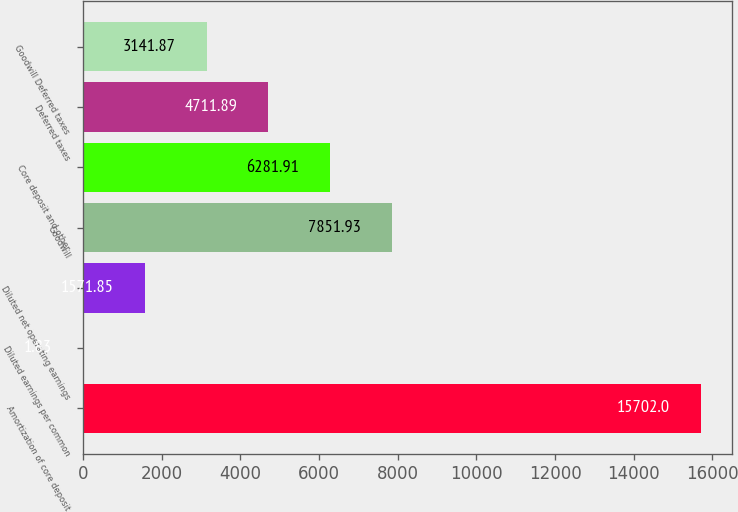Convert chart to OTSL. <chart><loc_0><loc_0><loc_500><loc_500><bar_chart><fcel>Amortization of core deposit<fcel>Diluted earnings per common<fcel>Diluted net operating earnings<fcel>Goodwill<fcel>Core deposit and other<fcel>Deferred taxes<fcel>Goodwill Deferred taxes<nl><fcel>15702<fcel>1.83<fcel>1571.85<fcel>7851.93<fcel>6281.91<fcel>4711.89<fcel>3141.87<nl></chart> 